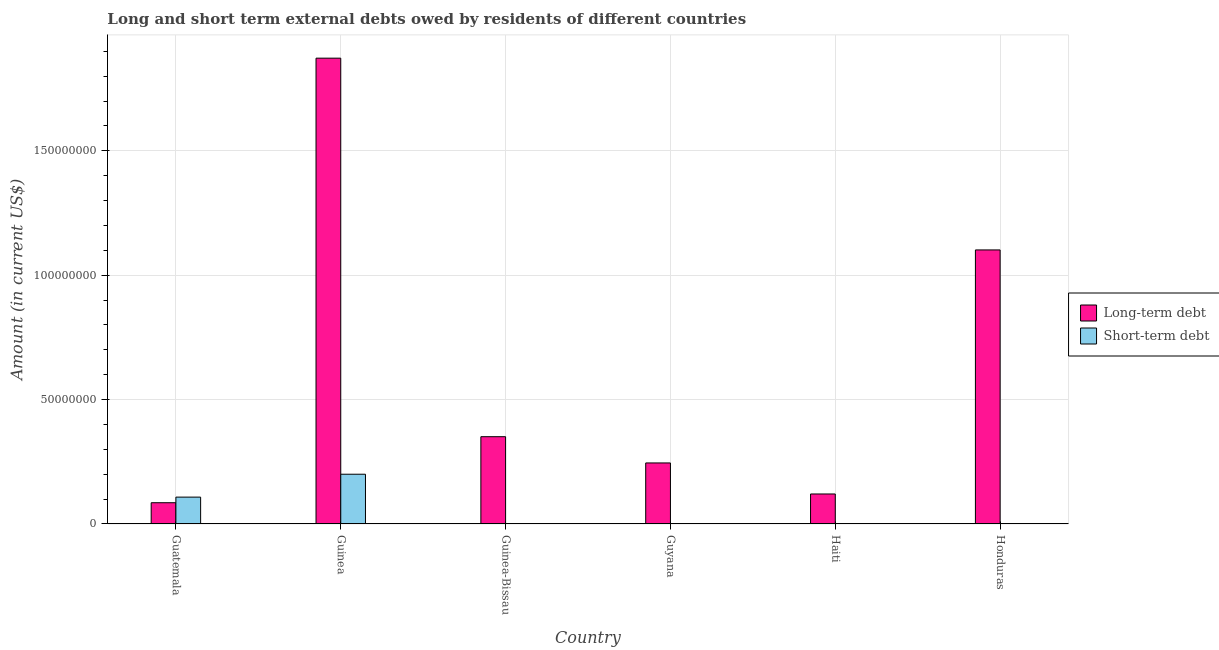How many different coloured bars are there?
Make the answer very short. 2. How many bars are there on the 4th tick from the left?
Provide a short and direct response. 1. How many bars are there on the 5th tick from the right?
Give a very brief answer. 2. What is the label of the 6th group of bars from the left?
Provide a succinct answer. Honduras. In how many cases, is the number of bars for a given country not equal to the number of legend labels?
Give a very brief answer. 4. What is the short-term debts owed by residents in Guinea?
Make the answer very short. 2.00e+07. Across all countries, what is the maximum long-term debts owed by residents?
Offer a very short reply. 1.87e+08. Across all countries, what is the minimum long-term debts owed by residents?
Keep it short and to the point. 8.54e+06. In which country was the short-term debts owed by residents maximum?
Provide a short and direct response. Guinea. What is the total long-term debts owed by residents in the graph?
Your answer should be compact. 3.78e+08. What is the difference between the long-term debts owed by residents in Guinea and that in Haiti?
Offer a terse response. 1.75e+08. What is the difference between the long-term debts owed by residents in Guyana and the short-term debts owed by residents in Haiti?
Your answer should be compact. 2.45e+07. What is the average short-term debts owed by residents per country?
Ensure brevity in your answer.  5.13e+06. What is the difference between the short-term debts owed by residents and long-term debts owed by residents in Guinea?
Make the answer very short. -1.67e+08. In how many countries, is the long-term debts owed by residents greater than 180000000 US$?
Keep it short and to the point. 1. What is the ratio of the long-term debts owed by residents in Guinea to that in Honduras?
Your response must be concise. 1.7. What is the difference between the highest and the second highest long-term debts owed by residents?
Offer a terse response. 7.71e+07. What is the difference between the highest and the lowest short-term debts owed by residents?
Offer a terse response. 2.00e+07. In how many countries, is the short-term debts owed by residents greater than the average short-term debts owed by residents taken over all countries?
Make the answer very short. 2. Is the sum of the long-term debts owed by residents in Guinea-Bissau and Haiti greater than the maximum short-term debts owed by residents across all countries?
Ensure brevity in your answer.  Yes. Are the values on the major ticks of Y-axis written in scientific E-notation?
Your answer should be very brief. No. Does the graph contain any zero values?
Make the answer very short. Yes. Where does the legend appear in the graph?
Offer a very short reply. Center right. What is the title of the graph?
Offer a very short reply. Long and short term external debts owed by residents of different countries. Does "Total Population" appear as one of the legend labels in the graph?
Offer a terse response. No. What is the label or title of the X-axis?
Give a very brief answer. Country. What is the Amount (in current US$) in Long-term debt in Guatemala?
Provide a succinct answer. 8.54e+06. What is the Amount (in current US$) of Short-term debt in Guatemala?
Your answer should be very brief. 1.08e+07. What is the Amount (in current US$) in Long-term debt in Guinea?
Offer a terse response. 1.87e+08. What is the Amount (in current US$) of Long-term debt in Guinea-Bissau?
Make the answer very short. 3.51e+07. What is the Amount (in current US$) in Short-term debt in Guinea-Bissau?
Ensure brevity in your answer.  0. What is the Amount (in current US$) of Long-term debt in Guyana?
Provide a succinct answer. 2.45e+07. What is the Amount (in current US$) in Long-term debt in Haiti?
Your answer should be compact. 1.21e+07. What is the Amount (in current US$) in Short-term debt in Haiti?
Offer a very short reply. 0. What is the Amount (in current US$) in Long-term debt in Honduras?
Keep it short and to the point. 1.10e+08. Across all countries, what is the maximum Amount (in current US$) of Long-term debt?
Your response must be concise. 1.87e+08. Across all countries, what is the maximum Amount (in current US$) of Short-term debt?
Offer a very short reply. 2.00e+07. Across all countries, what is the minimum Amount (in current US$) of Long-term debt?
Keep it short and to the point. 8.54e+06. Across all countries, what is the minimum Amount (in current US$) in Short-term debt?
Your answer should be compact. 0. What is the total Amount (in current US$) in Long-term debt in the graph?
Make the answer very short. 3.78e+08. What is the total Amount (in current US$) in Short-term debt in the graph?
Ensure brevity in your answer.  3.08e+07. What is the difference between the Amount (in current US$) in Long-term debt in Guatemala and that in Guinea?
Offer a very short reply. -1.79e+08. What is the difference between the Amount (in current US$) of Short-term debt in Guatemala and that in Guinea?
Make the answer very short. -9.20e+06. What is the difference between the Amount (in current US$) of Long-term debt in Guatemala and that in Guinea-Bissau?
Provide a succinct answer. -2.65e+07. What is the difference between the Amount (in current US$) in Long-term debt in Guatemala and that in Guyana?
Your answer should be very brief. -1.60e+07. What is the difference between the Amount (in current US$) of Long-term debt in Guatemala and that in Haiti?
Offer a terse response. -3.52e+06. What is the difference between the Amount (in current US$) in Long-term debt in Guatemala and that in Honduras?
Provide a succinct answer. -1.02e+08. What is the difference between the Amount (in current US$) in Long-term debt in Guinea and that in Guinea-Bissau?
Provide a succinct answer. 1.52e+08. What is the difference between the Amount (in current US$) in Long-term debt in Guinea and that in Guyana?
Offer a terse response. 1.63e+08. What is the difference between the Amount (in current US$) in Long-term debt in Guinea and that in Haiti?
Your answer should be compact. 1.75e+08. What is the difference between the Amount (in current US$) in Long-term debt in Guinea and that in Honduras?
Make the answer very short. 7.71e+07. What is the difference between the Amount (in current US$) of Long-term debt in Guinea-Bissau and that in Guyana?
Make the answer very short. 1.06e+07. What is the difference between the Amount (in current US$) in Long-term debt in Guinea-Bissau and that in Haiti?
Offer a terse response. 2.30e+07. What is the difference between the Amount (in current US$) of Long-term debt in Guinea-Bissau and that in Honduras?
Give a very brief answer. -7.51e+07. What is the difference between the Amount (in current US$) in Long-term debt in Guyana and that in Haiti?
Make the answer very short. 1.25e+07. What is the difference between the Amount (in current US$) of Long-term debt in Guyana and that in Honduras?
Your answer should be compact. -8.56e+07. What is the difference between the Amount (in current US$) in Long-term debt in Haiti and that in Honduras?
Offer a terse response. -9.81e+07. What is the difference between the Amount (in current US$) of Long-term debt in Guatemala and the Amount (in current US$) of Short-term debt in Guinea?
Keep it short and to the point. -1.15e+07. What is the average Amount (in current US$) in Long-term debt per country?
Offer a very short reply. 6.29e+07. What is the average Amount (in current US$) in Short-term debt per country?
Offer a terse response. 5.13e+06. What is the difference between the Amount (in current US$) of Long-term debt and Amount (in current US$) of Short-term debt in Guatemala?
Offer a terse response. -2.26e+06. What is the difference between the Amount (in current US$) in Long-term debt and Amount (in current US$) in Short-term debt in Guinea?
Make the answer very short. 1.67e+08. What is the ratio of the Amount (in current US$) in Long-term debt in Guatemala to that in Guinea?
Offer a very short reply. 0.05. What is the ratio of the Amount (in current US$) of Short-term debt in Guatemala to that in Guinea?
Your answer should be compact. 0.54. What is the ratio of the Amount (in current US$) in Long-term debt in Guatemala to that in Guinea-Bissau?
Your answer should be compact. 0.24. What is the ratio of the Amount (in current US$) in Long-term debt in Guatemala to that in Guyana?
Your answer should be very brief. 0.35. What is the ratio of the Amount (in current US$) in Long-term debt in Guatemala to that in Haiti?
Make the answer very short. 0.71. What is the ratio of the Amount (in current US$) of Long-term debt in Guatemala to that in Honduras?
Give a very brief answer. 0.08. What is the ratio of the Amount (in current US$) in Long-term debt in Guinea to that in Guinea-Bissau?
Your answer should be compact. 5.34. What is the ratio of the Amount (in current US$) of Long-term debt in Guinea to that in Guyana?
Give a very brief answer. 7.63. What is the ratio of the Amount (in current US$) in Long-term debt in Guinea to that in Haiti?
Offer a terse response. 15.53. What is the ratio of the Amount (in current US$) in Long-term debt in Guinea to that in Honduras?
Your response must be concise. 1.7. What is the ratio of the Amount (in current US$) in Long-term debt in Guinea-Bissau to that in Guyana?
Provide a succinct answer. 1.43. What is the ratio of the Amount (in current US$) in Long-term debt in Guinea-Bissau to that in Haiti?
Make the answer very short. 2.91. What is the ratio of the Amount (in current US$) in Long-term debt in Guinea-Bissau to that in Honduras?
Make the answer very short. 0.32. What is the ratio of the Amount (in current US$) of Long-term debt in Guyana to that in Haiti?
Your answer should be compact. 2.03. What is the ratio of the Amount (in current US$) in Long-term debt in Guyana to that in Honduras?
Make the answer very short. 0.22. What is the ratio of the Amount (in current US$) in Long-term debt in Haiti to that in Honduras?
Ensure brevity in your answer.  0.11. What is the difference between the highest and the second highest Amount (in current US$) in Long-term debt?
Provide a short and direct response. 7.71e+07. What is the difference between the highest and the lowest Amount (in current US$) of Long-term debt?
Provide a short and direct response. 1.79e+08. 